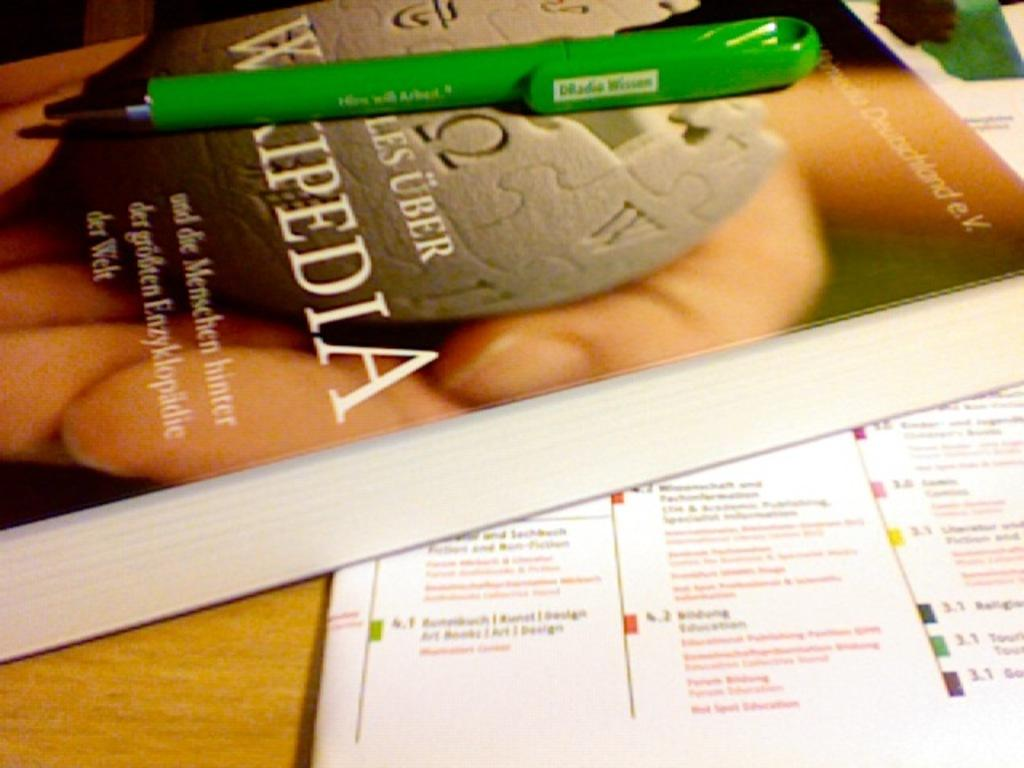<image>
Share a concise interpretation of the image provided. A book that says Wikipedia has a green pen on it. 